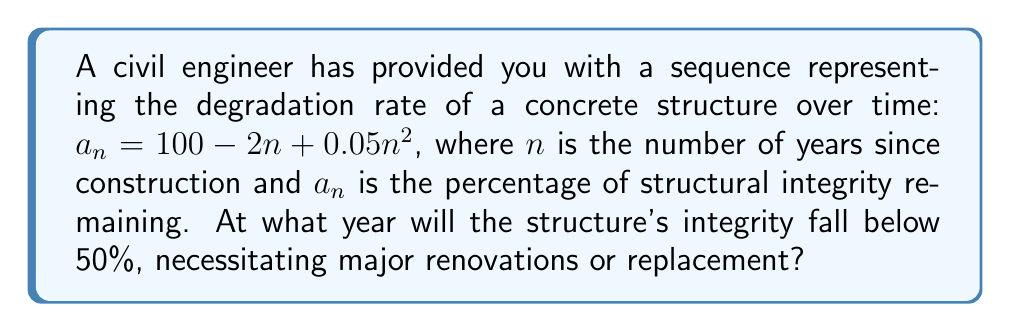Could you help me with this problem? To solve this problem, we need to find the value of $n$ where $a_n < 50$. Let's approach this step-by-step:

1) We start with the equation: $a_n = 100 - 2n + 0.05n^2$

2) We want to find when this becomes less than 50:
   $100 - 2n + 0.05n^2 < 50$

3) Rearranging the inequality:
   $0.05n^2 - 2n - 50 < 0$

4) This is a quadratic inequality. To solve it, we first find the roots of the quadratic equation:
   $0.05n^2 - 2n - 50 = 0$

5) Using the quadratic formula $\frac{-b \pm \sqrt{b^2 - 4ac}}{2a}$, where $a=0.05$, $b=-2$, and $c=-50$:

   $$n = \frac{2 \pm \sqrt{4 - 4(0.05)(-50)}}{2(0.05)} = \frac{2 \pm \sqrt{14}}{0.1}$$

6) Simplifying:
   $$n = 10 \pm 5\sqrt{14}$$

7) The roots are approximately 28.7 and 51.3.

8) Since we want $a_n < 50$, we need $n > 28.7$.

9) As we're dealing with years, we round up to the nearest whole number.
Answer: 29 years 